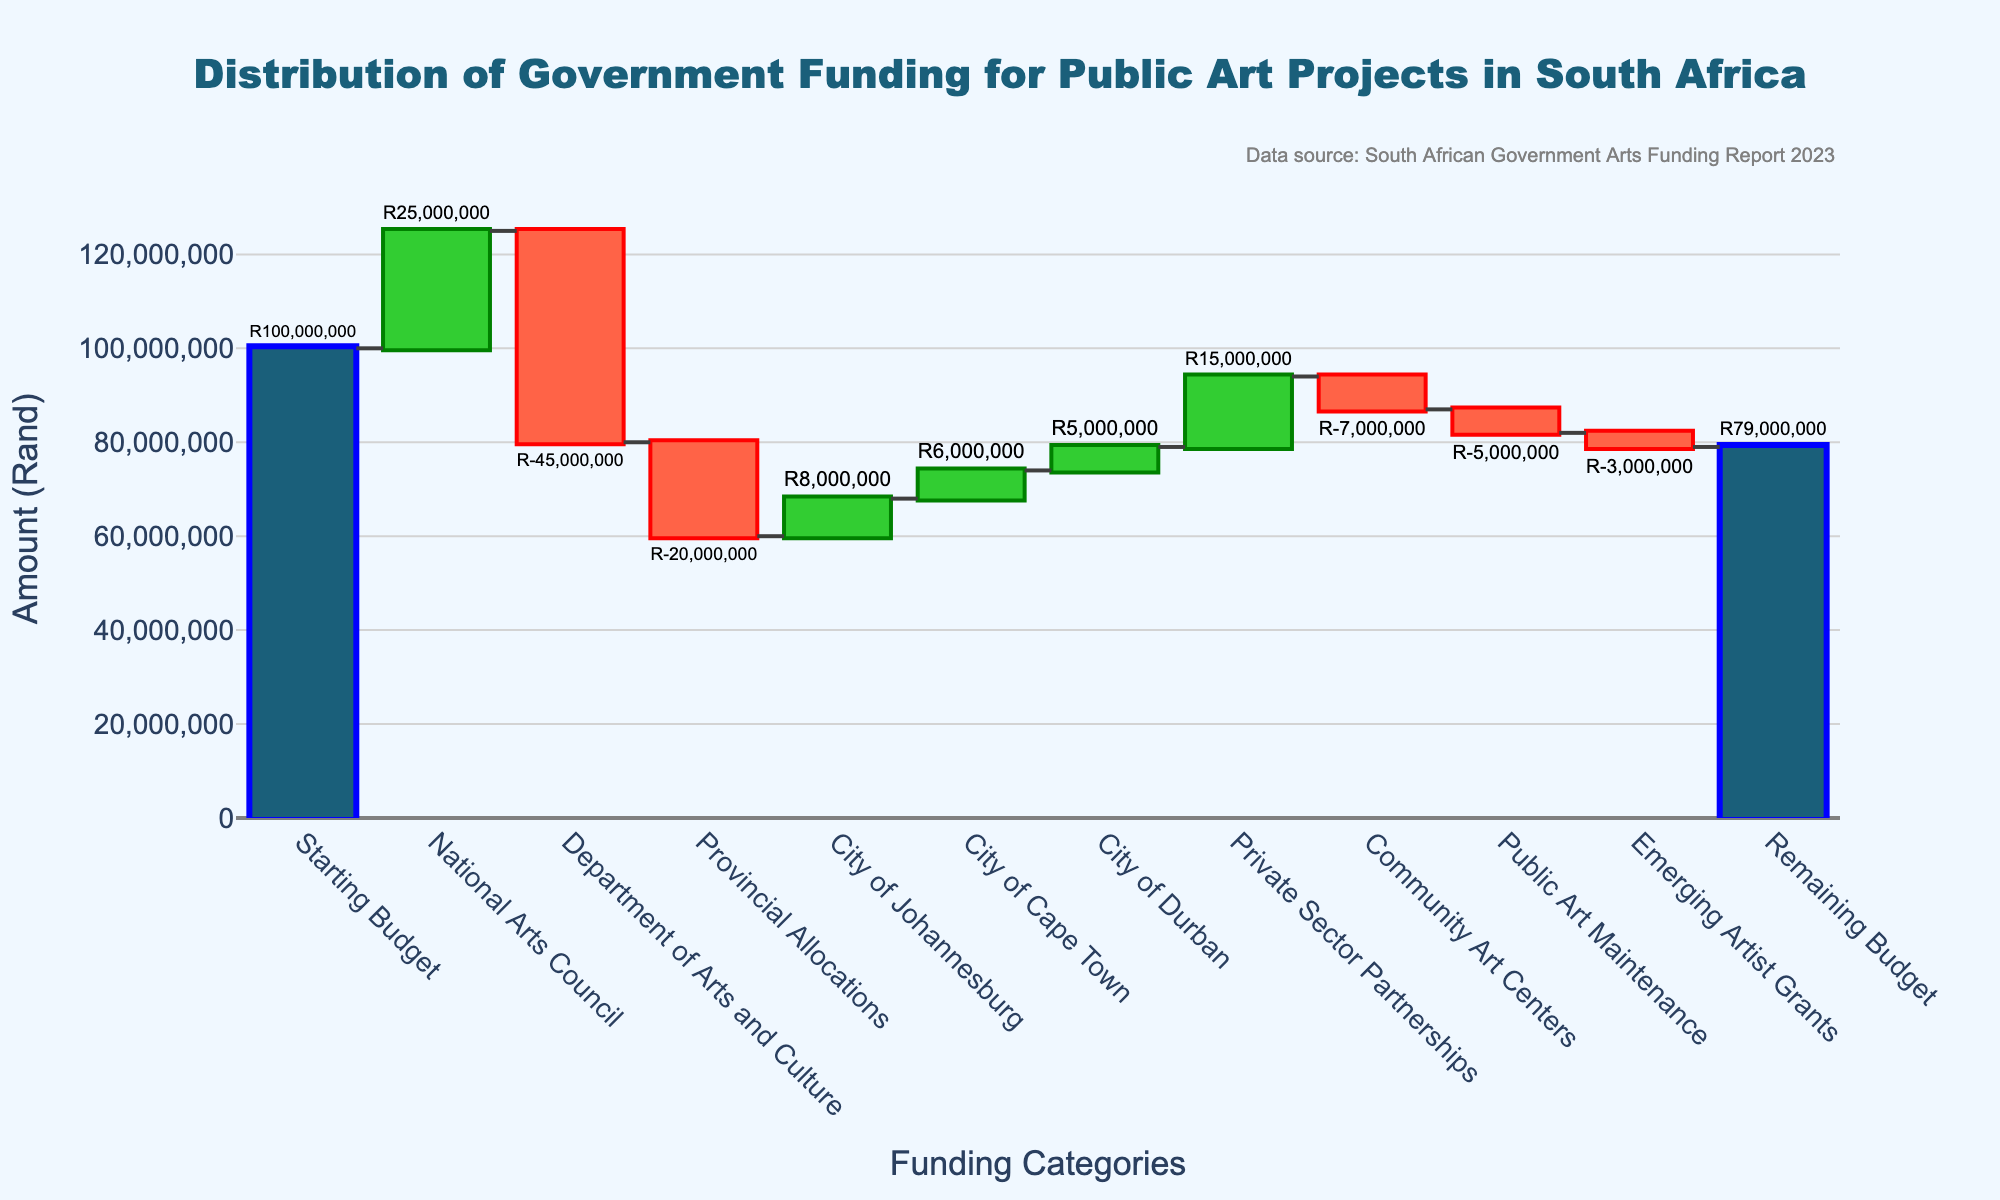What is the title of the plot? The title of the plot is usually found at the top of the figure and provides an overview of what the figure is about. In this case, it should indicate the distribution of government funding for public art projects in South Africa.
Answer: Distribution of Government Funding for Public Art Projects in South Africa What is the starting budget for the public art projects? The starting budget is the first category listed in the waterfall chart, which should show the initial amount before any allocations or deductions.
Answer: R100,000,000 Which category received the largest allocation of funds? To determine this, compare the values of all categories, looking for the highest positive value. The funding categories listed have respective values, and the highest one would be the largest allocation.
Answer: National Arts Council (R25,000,000) What is the remaining budget after all allocations and deductions? The remaining budget is the final category in the waterfall chart, which shows the total amount left after all the additions and subtractions from the initial budget.
Answer: R79,000,000 How much was allocated to the Private Sector Partnerships? Find the value associated with the "Private Sector Partnerships" category in the waterfall chart. This value represents the amount of money allocated to this category.
Answer: R15,000,000 Which categories resulted in a reduction of the budget? In a waterfall chart, categories that show negative values or bars that point downwards represent reductions. Identify these categories to answer the question.
Answer: Department of Arts and Culture, Provincial Allocations, Community Art Centers, Public Art Maintenance, Emerging Artist Grants Compare the allocation to the City of Johannesburg and the City of Durban. Which city received more funding? Compare the values associated with the "City of Johannesburg" and "City of Durban" categories. The city with the higher value received more funding.
Answer: City of Johannesburg (R8,000,000) What is the sum of the reductions in the budget? Add up all the negative values to find the total reduction from the initial budget. The categories with negative values are Department of Arts and Culture, Provincial Allocations, Community Art Centers, Public Art Maintenance, and Emerging Artist Grants.
Answer: R(-45,000,000) + R(-20,000,000) + R(-7,000,000) + R(-5,000,000) + R(-3,000,000) = R(-80,000,000) How does the allocation to the Department of Arts and Culture compare to the National Arts Council? Compare the values for these two categories to determine which one is greater and by how much. The Department of Arts and Culture has a negative value, meaning it is a deduction, whereas the National Arts Council has a positive allocation.
Answer: The National Arts Council received R25,000,000, while the Department of Arts and Culture resulted in R-45,000,000, a reduction What percentage of the initial budget was used to fund the Provincial Allocations? Calculate the percentage by dividing the amount for Provincial Allocations by the initial budget and then multiplying by 100.
Answer: (R20,000,000 / R100,000,000) * 100 = 20% 